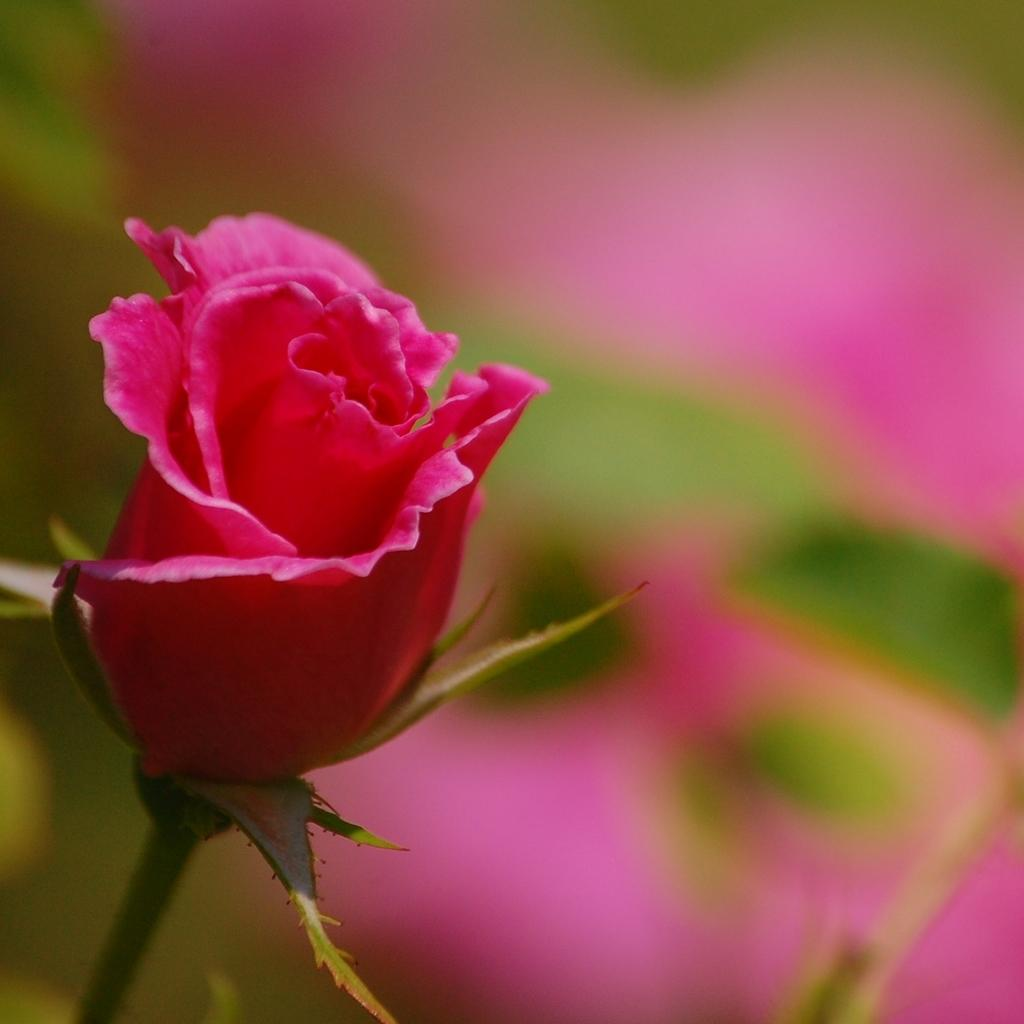What type of flower is in the picture? There is a pink rose in the picture. What color is the background behind the rose? The background of the rose is blue. What type of mailbox can be seen in the picture? There is no mailbox present in the picture; it features a pink rose with a blue background. How many trees are visible in the picture? There are no trees visible in the picture; it features a pink rose with a blue background. 